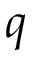Convert formula to latex. <formula><loc_0><loc_0><loc_500><loc_500>q</formula> 